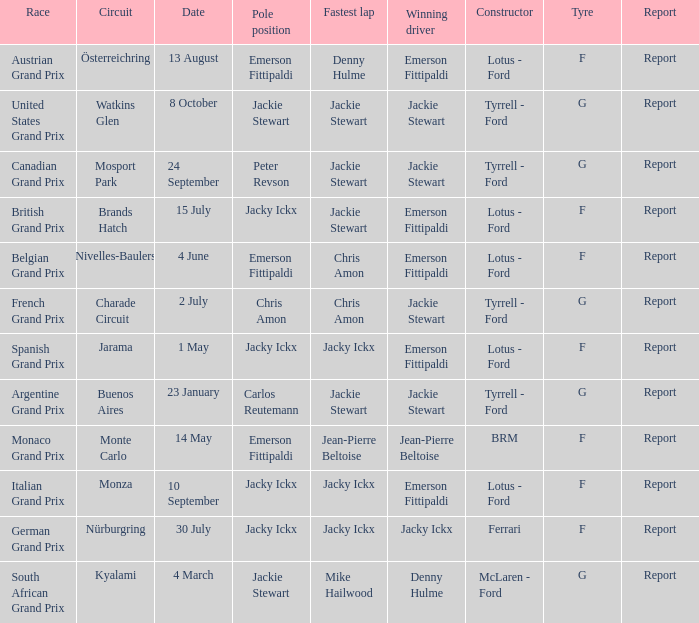I'm looking to parse the entire table for insights. Could you assist me with that? {'header': ['Race', 'Circuit', 'Date', 'Pole position', 'Fastest lap', 'Winning driver', 'Constructor', 'Tyre', 'Report'], 'rows': [['Austrian Grand Prix', 'Österreichring', '13 August', 'Emerson Fittipaldi', 'Denny Hulme', 'Emerson Fittipaldi', 'Lotus - Ford', 'F', 'Report'], ['United States Grand Prix', 'Watkins Glen', '8 October', 'Jackie Stewart', 'Jackie Stewart', 'Jackie Stewart', 'Tyrrell - Ford', 'G', 'Report'], ['Canadian Grand Prix', 'Mosport Park', '24 September', 'Peter Revson', 'Jackie Stewart', 'Jackie Stewart', 'Tyrrell - Ford', 'G', 'Report'], ['British Grand Prix', 'Brands Hatch', '15 July', 'Jacky Ickx', 'Jackie Stewart', 'Emerson Fittipaldi', 'Lotus - Ford', 'F', 'Report'], ['Belgian Grand Prix', 'Nivelles-Baulers', '4 June', 'Emerson Fittipaldi', 'Chris Amon', 'Emerson Fittipaldi', 'Lotus - Ford', 'F', 'Report'], ['French Grand Prix', 'Charade Circuit', '2 July', 'Chris Amon', 'Chris Amon', 'Jackie Stewart', 'Tyrrell - Ford', 'G', 'Report'], ['Spanish Grand Prix', 'Jarama', '1 May', 'Jacky Ickx', 'Jacky Ickx', 'Emerson Fittipaldi', 'Lotus - Ford', 'F', 'Report'], ['Argentine Grand Prix', 'Buenos Aires', '23 January', 'Carlos Reutemann', 'Jackie Stewart', 'Jackie Stewart', 'Tyrrell - Ford', 'G', 'Report'], ['Monaco Grand Prix', 'Monte Carlo', '14 May', 'Emerson Fittipaldi', 'Jean-Pierre Beltoise', 'Jean-Pierre Beltoise', 'BRM', 'F', 'Report'], ['Italian Grand Prix', 'Monza', '10 September', 'Jacky Ickx', 'Jacky Ickx', 'Emerson Fittipaldi', 'Lotus - Ford', 'F', 'Report'], ['German Grand Prix', 'Nürburgring', '30 July', 'Jacky Ickx', 'Jacky Ickx', 'Jacky Ickx', 'Ferrari', 'F', 'Report'], ['South African Grand Prix', 'Kyalami', '4 March', 'Jackie Stewart', 'Mike Hailwood', 'Denny Hulme', 'McLaren - Ford', 'G', 'Report']]} When did the Argentine Grand Prix race? 23 January. 